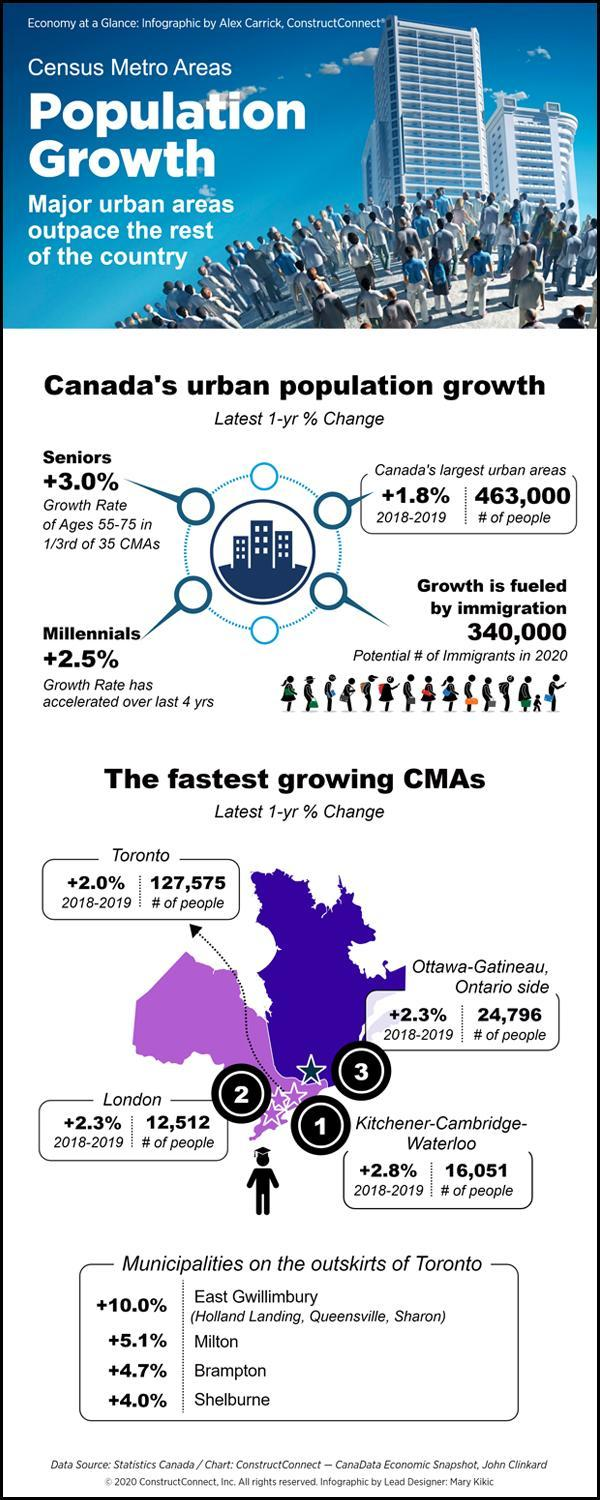How many municipalities of Toronto mentioned in this infographic?
Answer the question with a short phrase. 4 